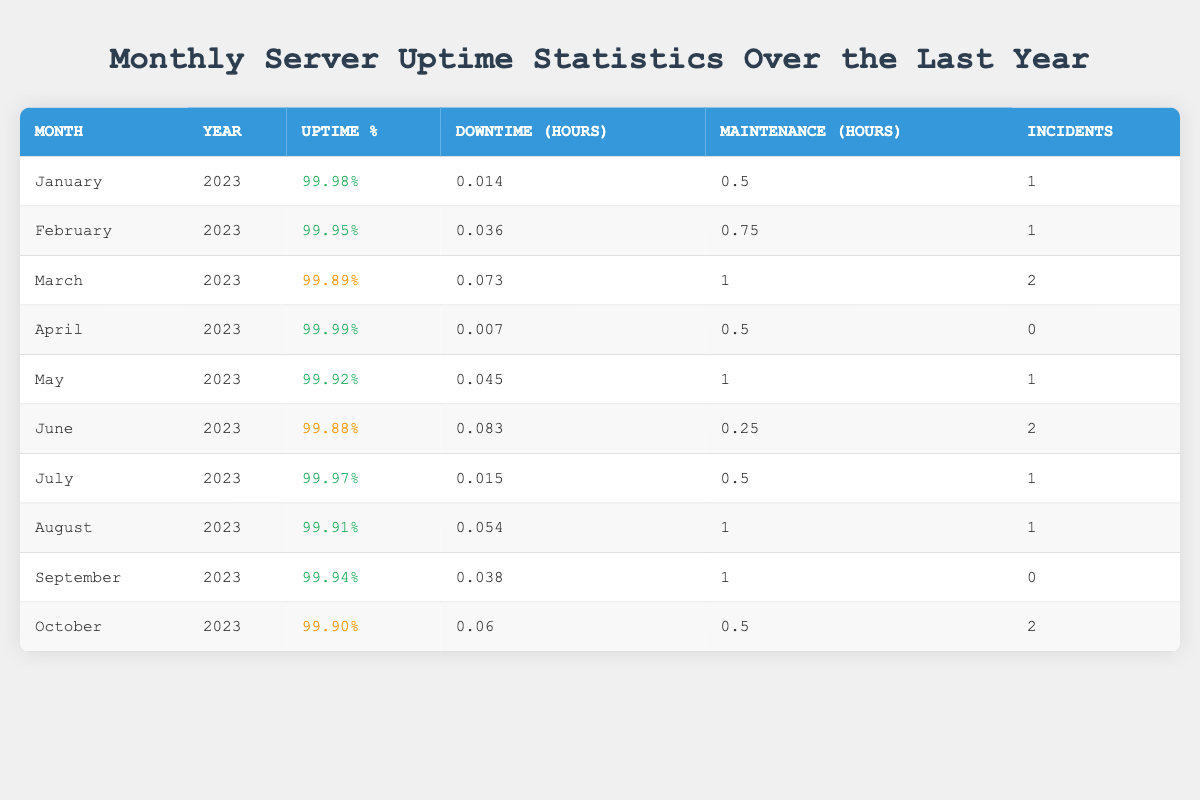What is the uptime percentage for March 2023? Referring to the table, the uptime percentage for March 2023 is directly listed in the relevant row.
Answer: 99.89% Which month had the highest uptime percentage? By scanning the uptime percentages across all months in the table, I see that April 2023 recorded the highest at 99.99%.
Answer: April 2023 How many incidents were recorded in June 2023? The number of incidents is specified in the June row of the table. It clearly states there were 2 incidents.
Answer: 2 What is the total downtime hours for the year so far (January to October 2023)? I will sum the downtime hours from January to October for the respective months: 0.014 + 0.036 + 0.073 + 0.007 + 0.045 + 0.083 + 0.015 + 0.054 + 0.038 + 0.06 = 0.455.
Answer: 0.455 Was there any month with a downtime of less than 0.1 hours? Looking at the downtime hours for all months in the table, I can see that every month has downtime hours less than 0.1. Thus, the answer is yes.
Answer: Yes What is the average uptime percentage for the months from January to June 2023? To calculate the average uptime percentage, I sum the percentages from January (99.98), February (99.95), March (99.89), April (99.99), May (99.92), and June (99.88): 99.98 + 99.95 + 99.89 + 99.99 + 99.92 + 99.88 = 599.51. Then divide by 6 (the number of months): 599.51 / 6 = 99.9185, which I round to 99.92.
Answer: 99.92 In how many months was there maintenance of more than 0.5 hours? I will check the maintenance hours for each month. The months with maintenance exceeding 0.5 hours are January (0.5), February (0.75), March (1.0), May (1.0), August (1.0), and September (1.0), resulting in a total of 5 months.
Answer: 5 For which month was the number of incidents zero? By inspecting the table, I find that April 2023 has zero incidents listed.
Answer: April 2023 What was the downtime in February 2023 compared to March 2023? For February 2023, the downtime was 0.036 hours, and for March 2023, it was 0.073 hours. Since 0.073 is greater than 0.036, March had more downtime than February.
Answer: March had more downtime 